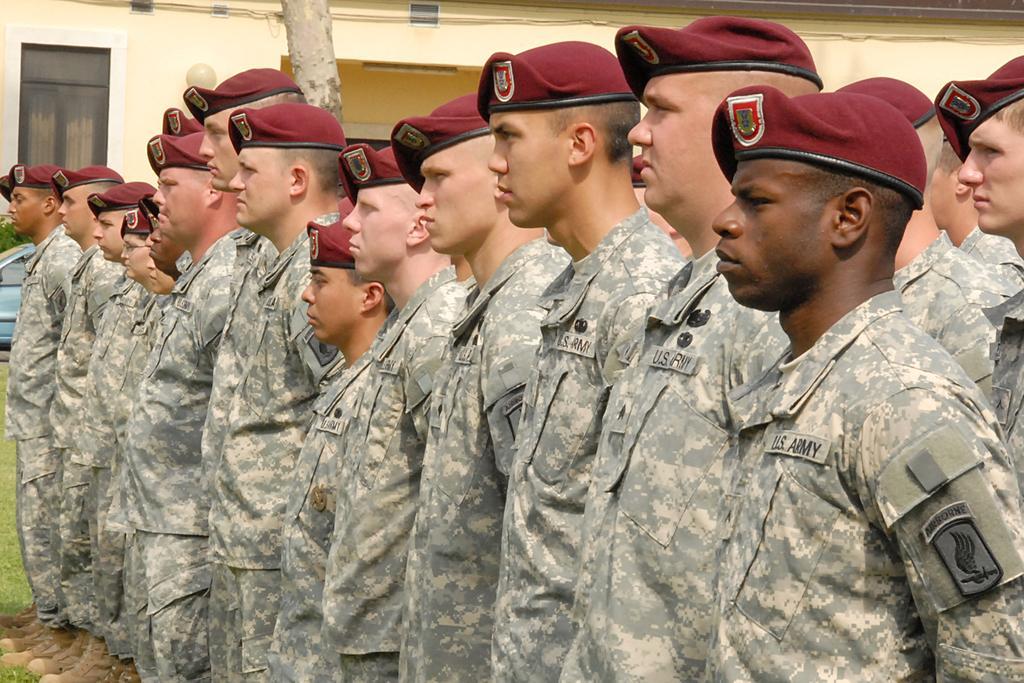Can you describe this image briefly? In the foreground of this image, there are men standing on the grass. In the background, there is a vehicle, a tree trunk and the building. 